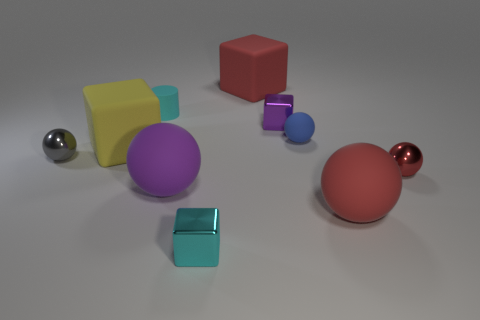Subtract all purple balls. How many balls are left? 4 Subtract all big red spheres. How many spheres are left? 4 Subtract all gray cubes. Subtract all blue cylinders. How many cubes are left? 4 Subtract all cubes. How many objects are left? 6 Add 8 tiny blue balls. How many tiny blue balls are left? 9 Add 3 blocks. How many blocks exist? 7 Subtract 0 red cylinders. How many objects are left? 10 Subtract all cyan matte cylinders. Subtract all small cyan metal objects. How many objects are left? 8 